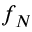Convert formula to latex. <formula><loc_0><loc_0><loc_500><loc_500>f _ { N }</formula> 